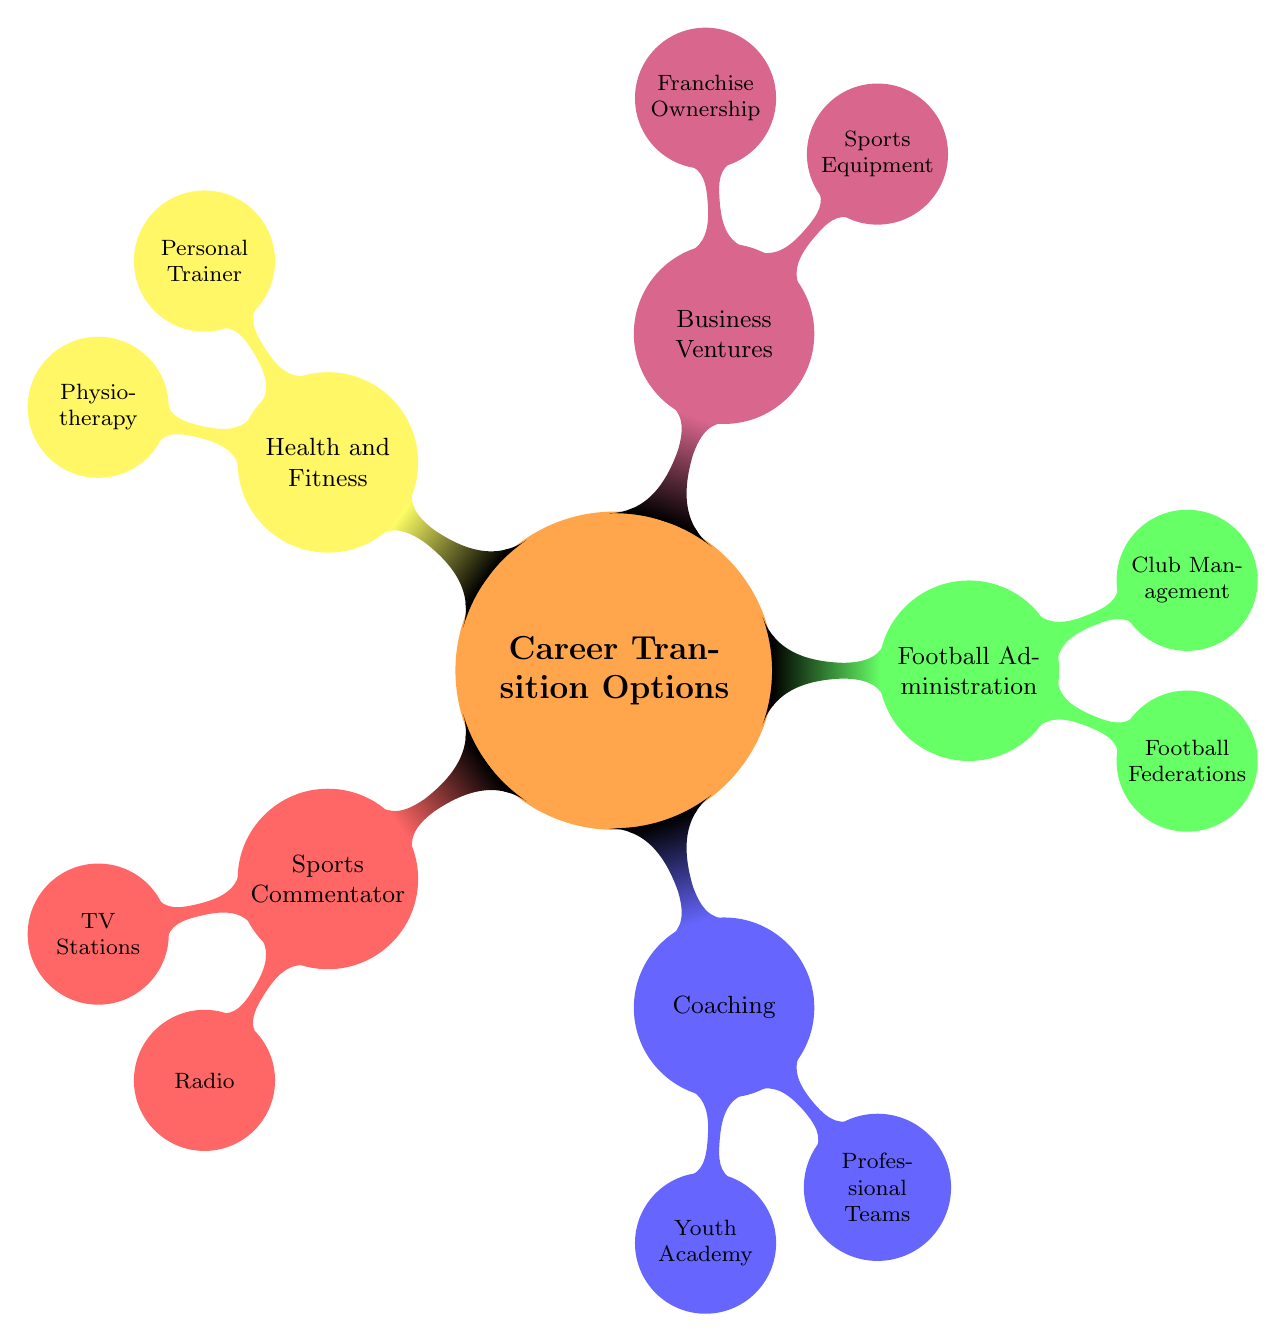What's the first node under Career Transition Options? The first node directly under the main node "Career Transition Options" is "Sports Commentator". This can be found by looking for the first child node connected to the central concept.
Answer: Sports Commentator How many main career transition options are listed? Count the primary child nodes under "Career Transition Options". There are five main options: Sports Commentator, Coaching, Football Administration, Business Ventures, and Health and Fitness.
Answer: 5 What is a potential franchise ownership venture listed? The category of "Business Ventures" contains "Franchise Ownership" as a child node. Under this, one of the options listed is "Café". This can be retrieved by checking the second layer underneath 'Business Ventures'.
Answer: Café Which career transition option is associated with youth development? Under the "Coaching" branch, "Youth Academy" is specifically related to the development of young players. Recognizing the context of coaching leads to this connection.
Answer: Youth Academy What is one example of a football federation noted for career transition? Within the "Football Administration" section, "Football Federations" has "Croatian Football Federation" listed as one of its child nodes. This can be identified as a governing body directly related to football.
Answer: Croatian Football Federation How are the options for health and fitness categorized? The "Health and Fitness" main branch has two child nodes: "Personal Trainer" and "Physiotherapy". This is clear from observing the immediate subdivisions under the Health and Fitness section.
Answer: Personal Trainer, Physiotherapy What type of business venture focuses on sports equipment? The "Business Ventures" branch contains "Sports Equipment" specifically under one of its child nodes. This is identified in a section focusing on various business options tied to their personal experiences.
Answer: Sports Equipment Which specific role is found in the club management sector? In the "Football Administration" area, under "Club Management", "Technical Director" is one of the roles listed. By checking the sub-nodes under that category, this specific role can be pinpointed.
Answer: Technical Director 